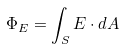Convert formula to latex. <formula><loc_0><loc_0><loc_500><loc_500>\Phi _ { E } = \int _ { S } E \cdot d A</formula> 